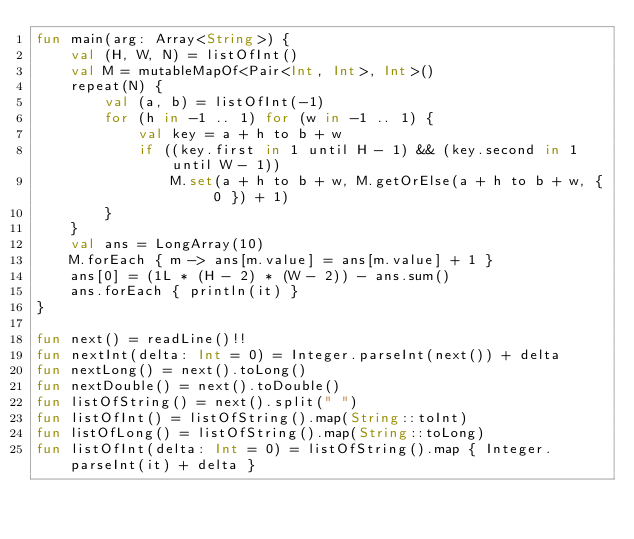<code> <loc_0><loc_0><loc_500><loc_500><_Kotlin_>fun main(arg: Array<String>) {
    val (H, W, N) = listOfInt()
    val M = mutableMapOf<Pair<Int, Int>, Int>()
    repeat(N) {
        val (a, b) = listOfInt(-1)
        for (h in -1 .. 1) for (w in -1 .. 1) {
            val key = a + h to b + w
            if ((key.first in 1 until H - 1) && (key.second in 1 until W - 1))
                M.set(a + h to b + w, M.getOrElse(a + h to b + w, { 0 }) + 1)
        }
    }
    val ans = LongArray(10)
    M.forEach { m -> ans[m.value] = ans[m.value] + 1 }
    ans[0] = (1L * (H - 2) * (W - 2)) - ans.sum()
    ans.forEach { println(it) }
}

fun next() = readLine()!!
fun nextInt(delta: Int = 0) = Integer.parseInt(next()) + delta
fun nextLong() = next().toLong()
fun nextDouble() = next().toDouble()
fun listOfString() = next().split(" ")
fun listOfInt() = listOfString().map(String::toInt)
fun listOfLong() = listOfString().map(String::toLong)
fun listOfInt(delta: Int = 0) = listOfString().map { Integer.parseInt(it) + delta }

</code> 